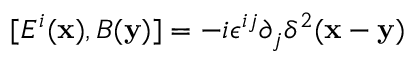Convert formula to latex. <formula><loc_0><loc_0><loc_500><loc_500>[ E ^ { i } ( { x } ) , B ( { y } ) ] = - i \epsilon ^ { i j } \partial _ { j } \delta ^ { 2 } ( { x } - { y } )</formula> 